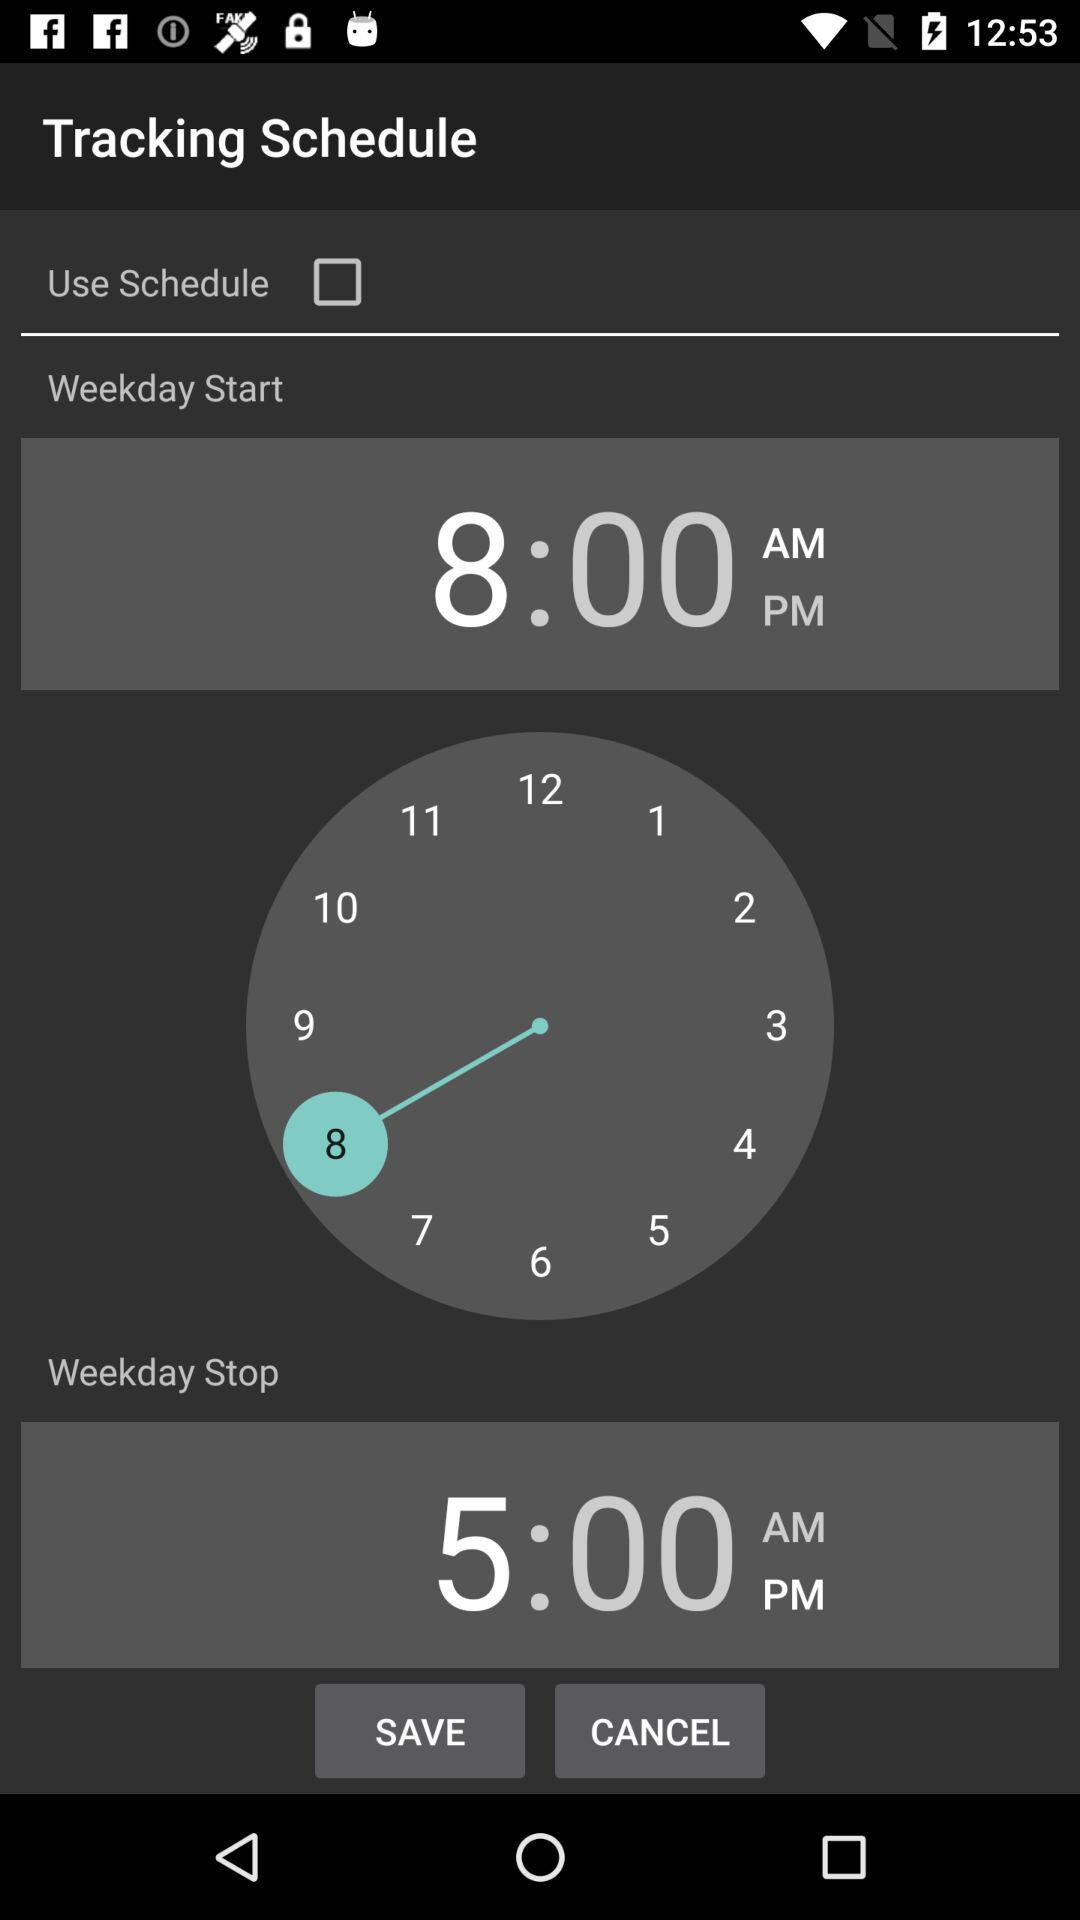What is the name of the application? The name of the application is "Tracking Schedule". 